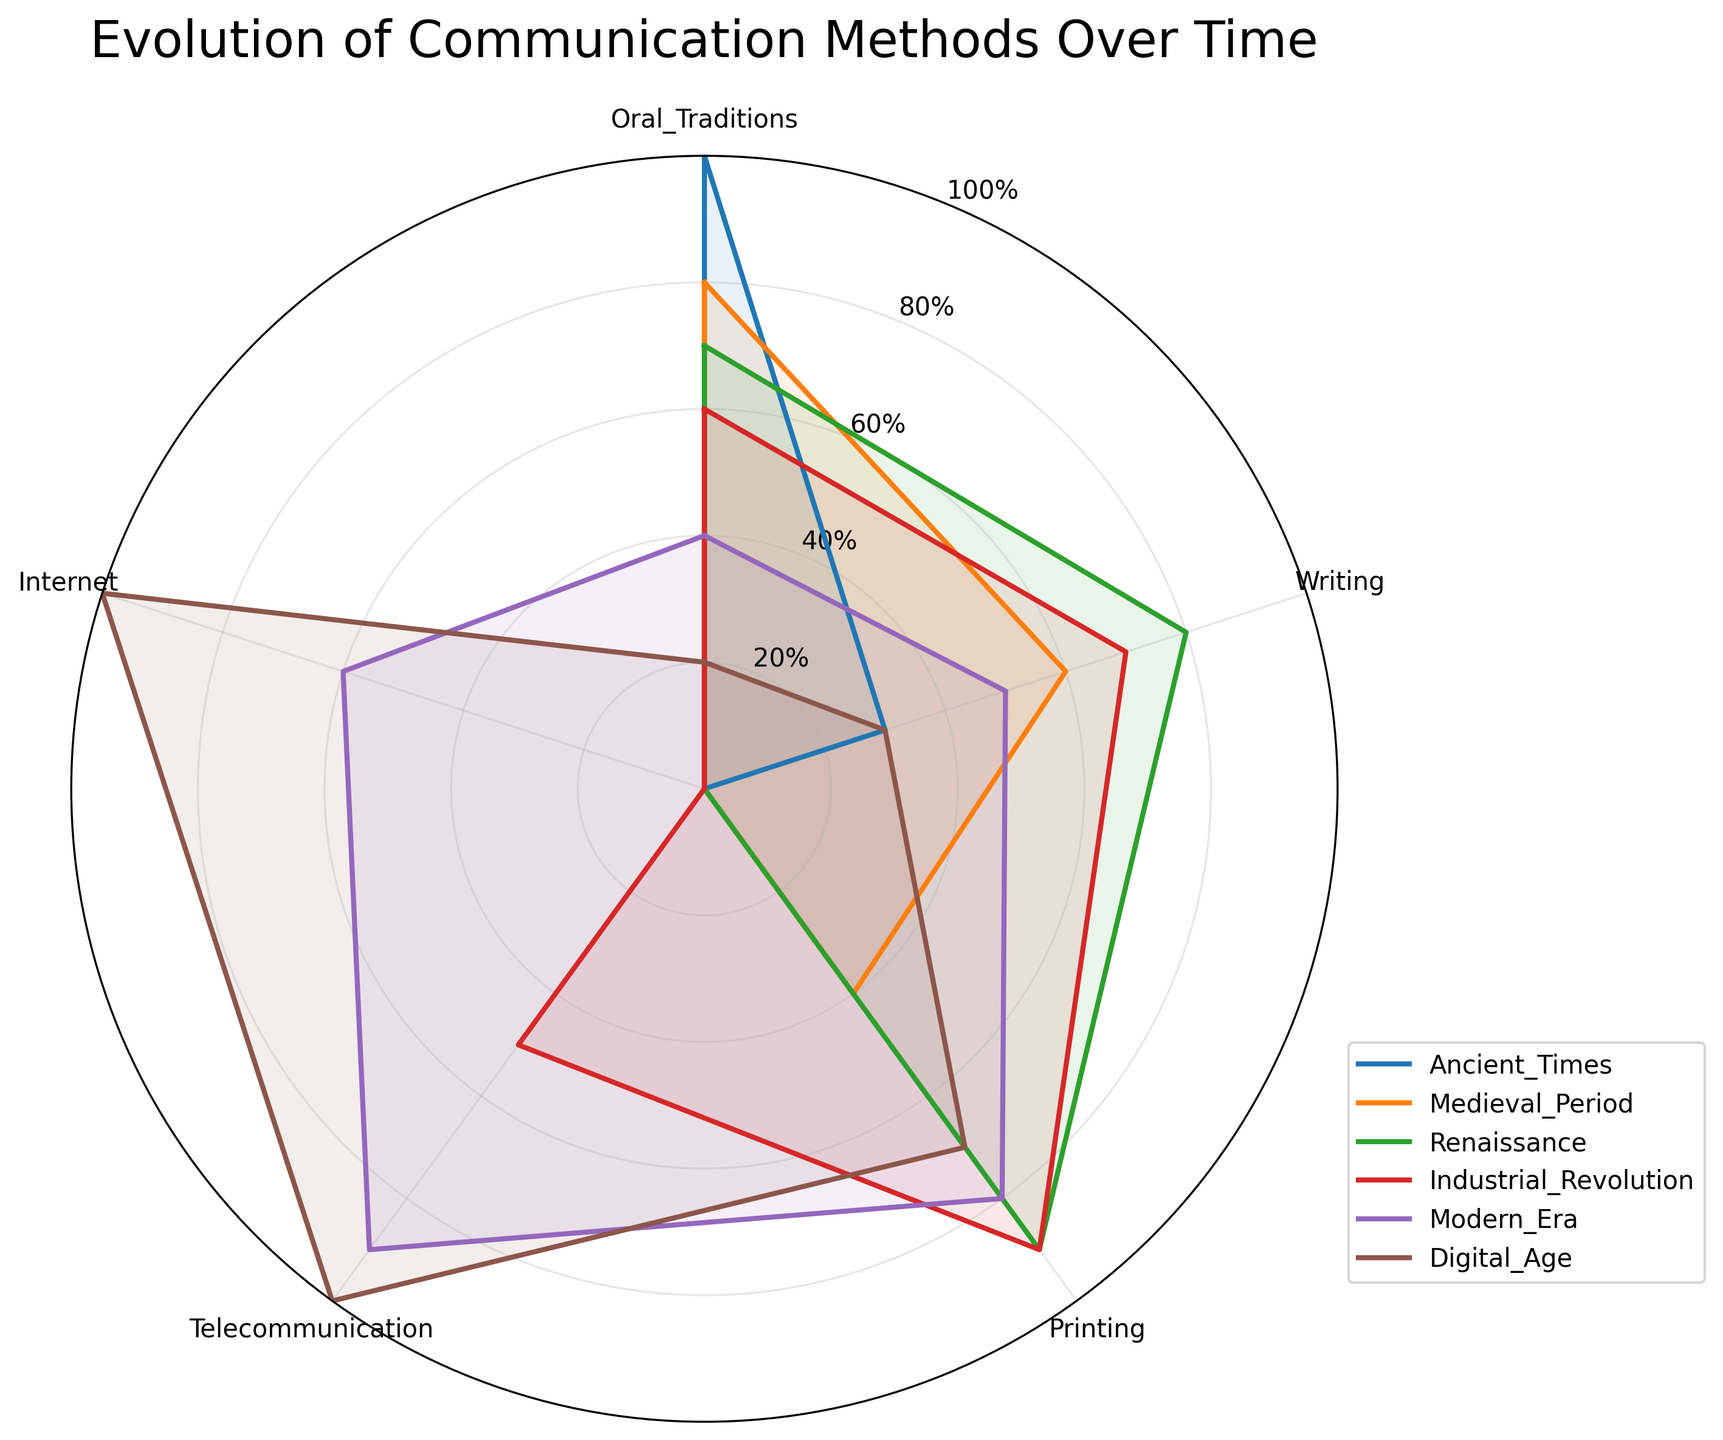How many historical periods are represented in the radar chart? We need to count the number of distinct historical periods mentioned in the legend of the chart. From the data, the periods are: Ancient Times, Medieval Period, Renaissance, Industrial Revolution, Modern Era, Digital Age.
Answer: 6 Which historical period shows the highest usage of telecommunication? We compare the telecommunication values across all historical periods. The period with the highest value for telecommunication is the period with the most extended length in this category. From the data, the Digital Age has the highest telecommunication value of 100.
Answer: Digital Age In the Renaissance, how does the usage of writing compare to oral traditions? We look at the respective lengths of the values for writing and oral traditions in the Renaissance segment. The writing value is 80, and the oral tradition value is 70. Thus, writing is higher than oral traditions in the Renaissance.
Answer: Writing is higher What is the total value of communication methods in the Industrial Revolution? We sum the individual values of Oral Traditions, Writing, Printing, Telecommunication, and Internet for the Industrial Revolution. The values are: 60 + 70 + 90 + 50 + 0. Summing these up gives 270.
Answer: 270 Which historical period has the highest overall utilization of communication methods? To find this, we must sum the values of all communication methods for each period and then compare. The sum for each period is: 
Ancient Times: 130,
Medieval Period: 180,
Renaissance: 240,
Industrial Revolution: 270,
Modern Era: 320,
Digital Age: 320.
The highest sum is 320, occurring in the Modern Era and Digital Age.
Answer: Modern Era and Digital Age How does the usage of oral traditions change over time? We observe the oral traditions values across the historical periods and note the trend. Values are: Ancient Times (100), Medieval Period (80), Renaissance (70), Industrial Revolution (60), Modern Era (40), Digital Age (20). This shows a decreasing trend.
Answer: Decreases What time period experienced the most significant shift towards internet usage? We check the data for the Internet values across periods. The biggest increase occurs between the Modern Era (60) and the Digital Age (100), indicating a significant shift towards internet usage in the Digital Age.
Answer: Digital Age Compare the usage of printing between the Medieval Period and the Industrial Revolution. We look at the values for printing in the two periods. Medieval Period: 40, Industrial Revolution: 90. Industrial Revolution has a higher value.
Answer: Industrial Revolution is higher 